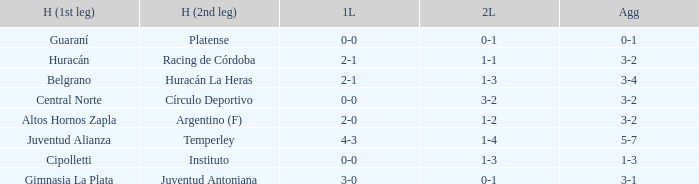Who played at home for the 2nd leg with a score of 1-2? Argentino (F). 